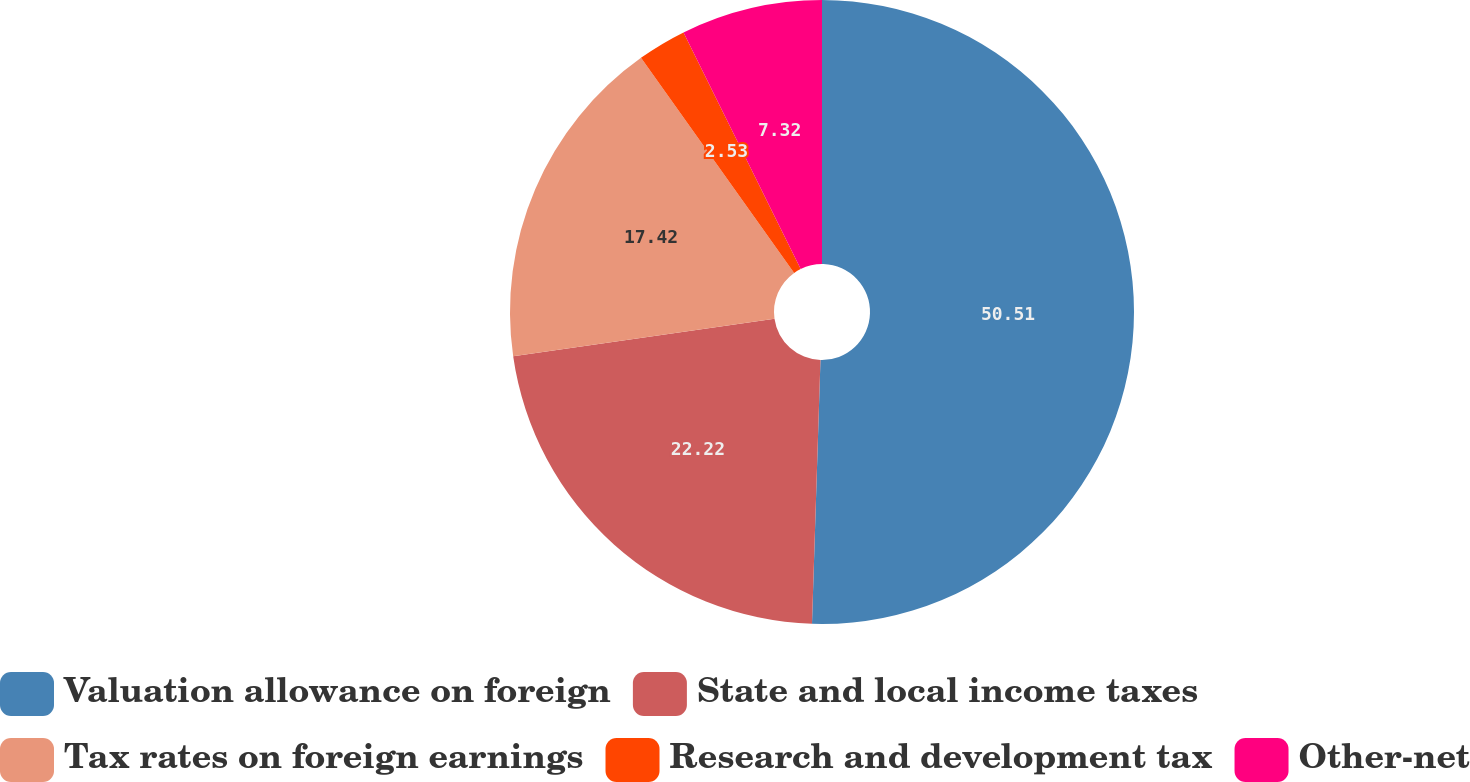Convert chart to OTSL. <chart><loc_0><loc_0><loc_500><loc_500><pie_chart><fcel>Valuation allowance on foreign<fcel>State and local income taxes<fcel>Tax rates on foreign earnings<fcel>Research and development tax<fcel>Other-net<nl><fcel>50.51%<fcel>22.22%<fcel>17.42%<fcel>2.53%<fcel>7.32%<nl></chart> 